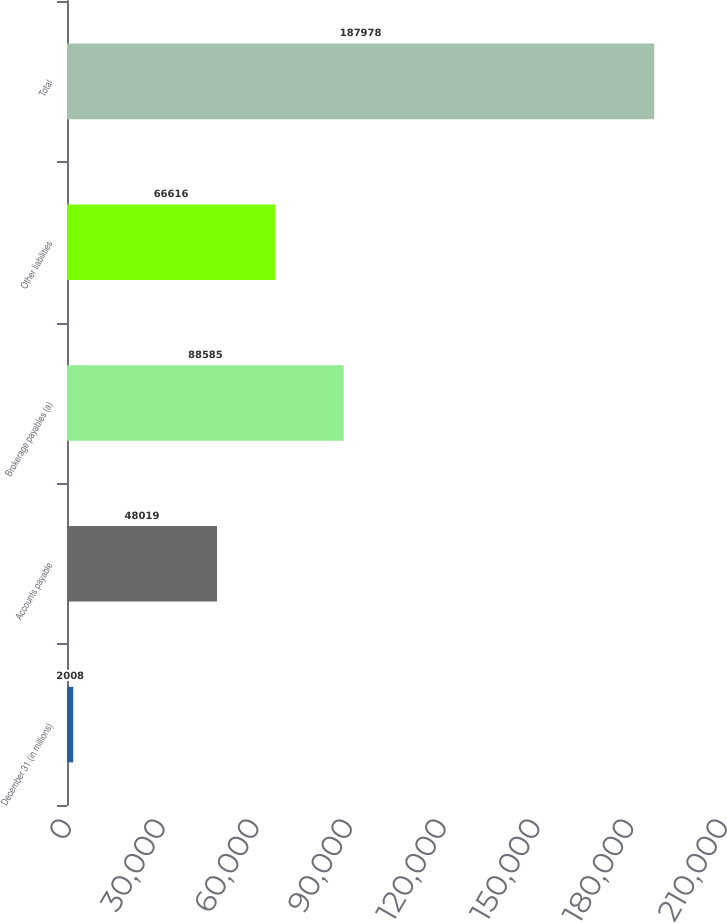<chart> <loc_0><loc_0><loc_500><loc_500><bar_chart><fcel>December 31 (in millions)<fcel>Accounts payable<fcel>Brokerage payables (a)<fcel>Other liabilities<fcel>Total<nl><fcel>2008<fcel>48019<fcel>88585<fcel>66616<fcel>187978<nl></chart> 